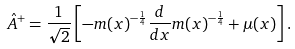<formula> <loc_0><loc_0><loc_500><loc_500>& \hat { A } ^ { + } = \frac { 1 } { \sqrt { 2 } } \left [ - m ( x ) ^ { - \frac { 1 } { 4 } } \frac { d } { d x } m ( x ) ^ { - \frac { 1 } { 4 } } + \mu ( x ) \right ] .</formula> 